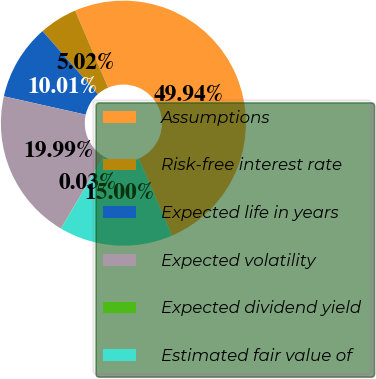<chart> <loc_0><loc_0><loc_500><loc_500><pie_chart><fcel>Assumptions<fcel>Risk-free interest rate<fcel>Expected life in years<fcel>Expected volatility<fcel>Expected dividend yield<fcel>Estimated fair value of<nl><fcel>49.93%<fcel>5.02%<fcel>10.01%<fcel>19.99%<fcel>0.03%<fcel>15.0%<nl></chart> 